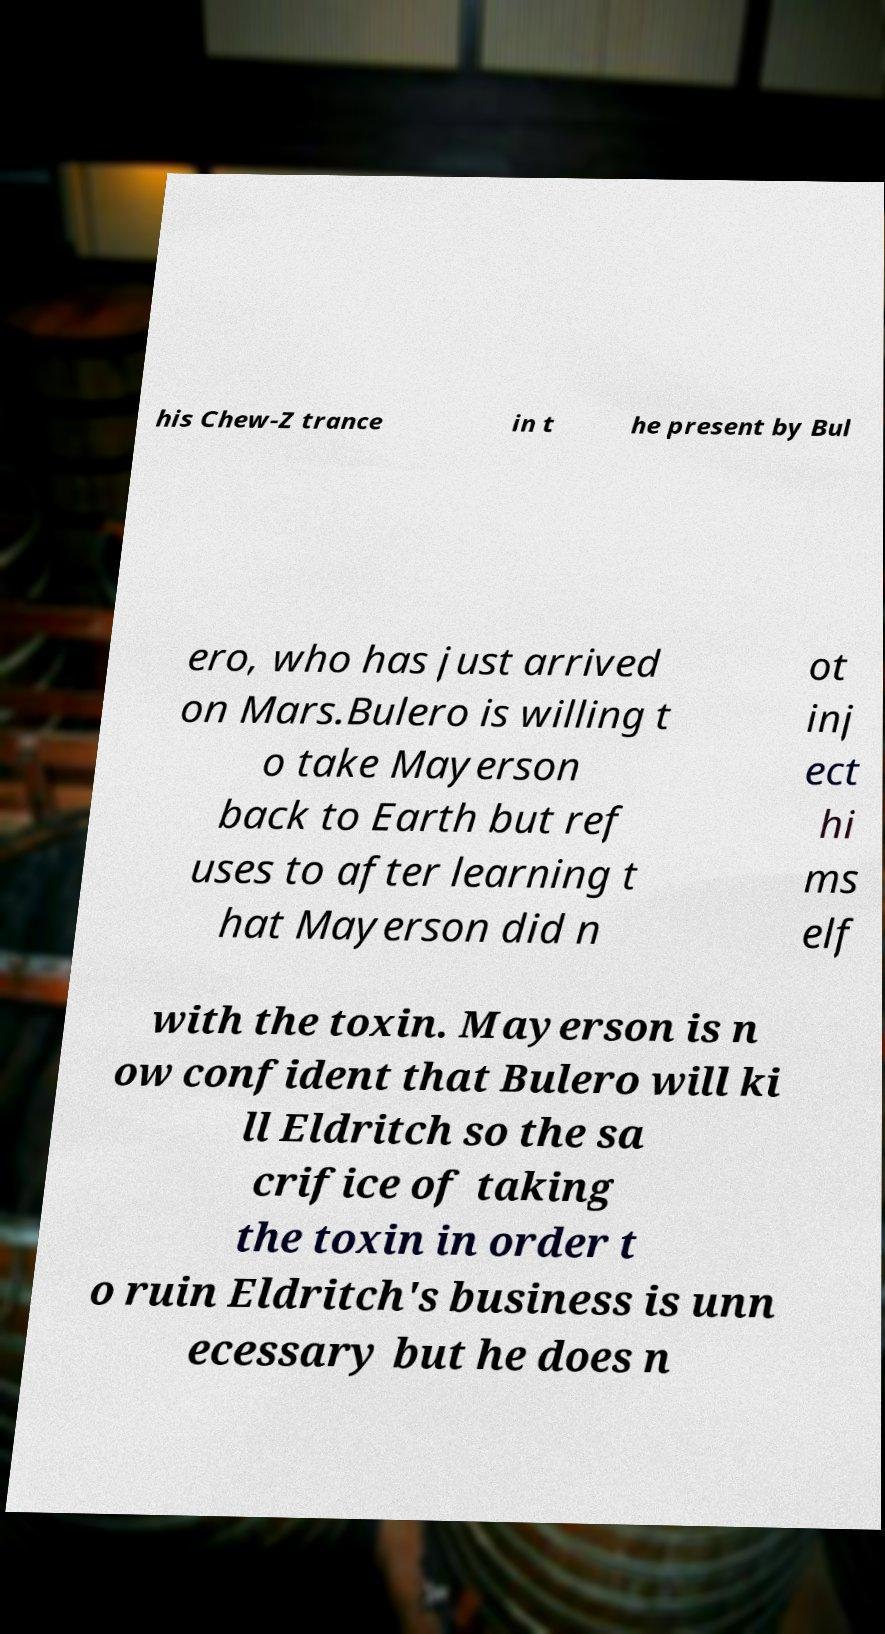Can you read and provide the text displayed in the image?This photo seems to have some interesting text. Can you extract and type it out for me? his Chew-Z trance in t he present by Bul ero, who has just arrived on Mars.Bulero is willing t o take Mayerson back to Earth but ref uses to after learning t hat Mayerson did n ot inj ect hi ms elf with the toxin. Mayerson is n ow confident that Bulero will ki ll Eldritch so the sa crifice of taking the toxin in order t o ruin Eldritch's business is unn ecessary but he does n 